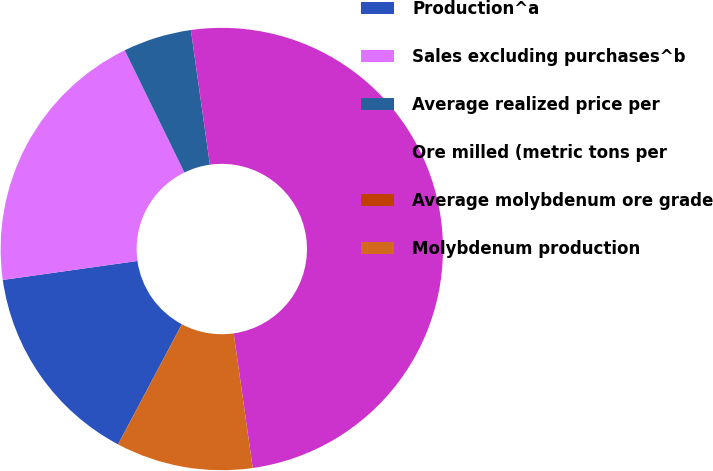Convert chart to OTSL. <chart><loc_0><loc_0><loc_500><loc_500><pie_chart><fcel>Production^a<fcel>Sales excluding purchases^b<fcel>Average realized price per<fcel>Ore milled (metric tons per<fcel>Average molybdenum ore grade<fcel>Molybdenum production<nl><fcel>15.0%<fcel>20.0%<fcel>5.0%<fcel>50.0%<fcel>0.0%<fcel>10.0%<nl></chart> 